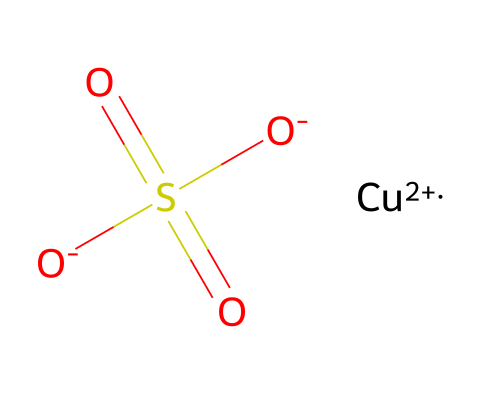What is the name of the chemical represented by this SMILES? The SMILES representation corresponds to a chemical that contains copper and sulfate ions, commonly known as copper sulfate.
Answer: copper sulfate How many oxygen atoms are present in the structure? By analyzing the SMILES, we see there are four oxygen atoms mentioned; two are part of the sulfate group (which has sulfur and is indicated by the 'S(=O)(=O)' section), and the others appear individually.
Answer: four What type of ions are in this chemical structure? This SMILES shows the presence of a copper ion (Cu+2) and sulfate ions (represented by the SO4 structure). The presence of these ions identifies the ionic nature of this compound.
Answer: ionic Does this chemical have acidic properties? Looking at the sulfate ions (which contain a sulfur atom double-bonded to two oxygen atoms), we infer its potential for generating acidity in solution, indicating it can act as an acid.
Answer: yes What role does copper play in this fungicide? Copper in this structure acts as a biocidal agent, which is crucial for the antifungal activity of this compound. The presence of copper ions is essential for disrupting fungal cell processes.
Answer: biocidal agent How many sulfur atoms are in this compound? By examining the SMILES, we note that only one sulfur atom appears in the structure, as indicated right before the oxygen atoms in the sulfate grouping.
Answer: one Is copper sulfate approved for organic farming? Copper sulfate is listed as a permitted fungicide for organic farming under specific regulations, conforming to the requirements for organic fungicides.
Answer: yes 